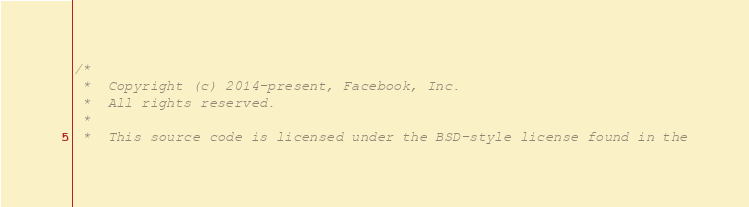Convert code to text. <code><loc_0><loc_0><loc_500><loc_500><_ObjectiveC_>/*
 *  Copyright (c) 2014-present, Facebook, Inc.
 *  All rights reserved.
 *
 *  This source code is licensed under the BSD-style license found in the</code> 